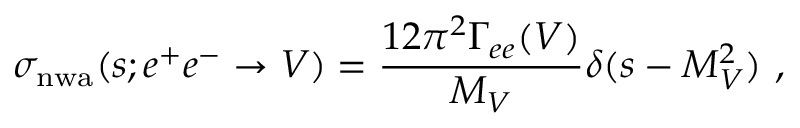<formula> <loc_0><loc_0><loc_500><loc_500>\sigma _ { n w a } ( s ; e ^ { + } e ^ { - } \to V ) = \frac { 1 2 \pi ^ { 2 } \Gamma _ { e e } ( V ) } { M _ { V } } \delta ( s - M _ { V } ^ { 2 } ) \ ,</formula> 